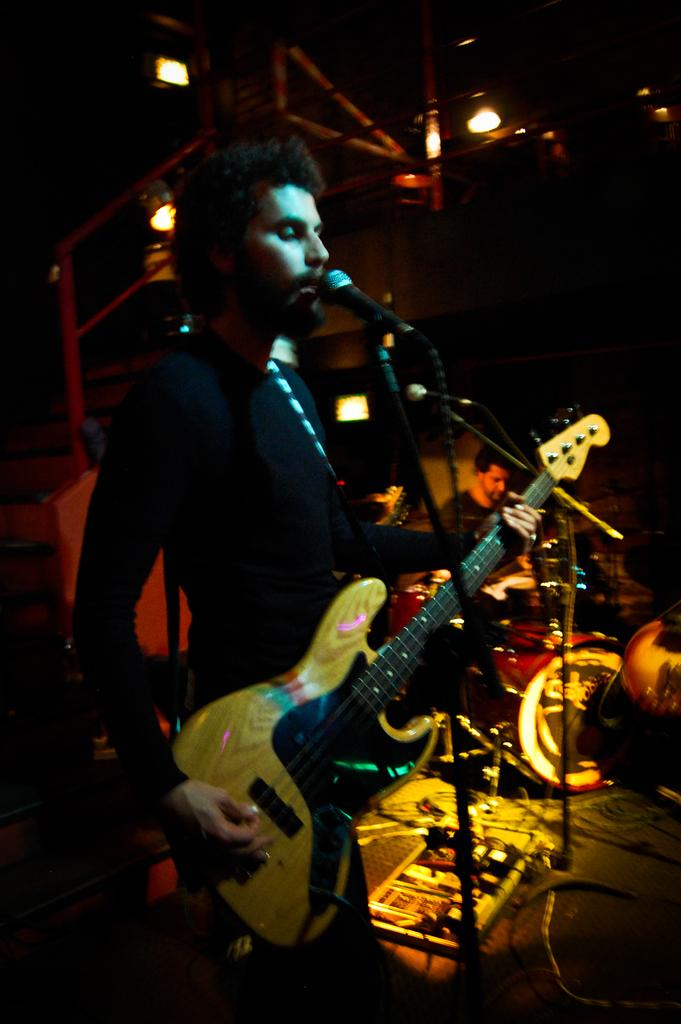What is the man in the image doing? The man is playing a guitar and singing in the image. What object is the man using to amplify his voice? The man is in front of a microphone. What can be seen in the background of the image? There are lights visible in the image. What other musical instrument is the man playing? The man is playing musical instruments, but the provided facts only mention the guitar. What language is the man singing in the image? The provided facts do not mention the language the man is singing in, so it cannot be determined from the image. --- Facts: 1. There is a car in the image. 2. The car is red. 3. The car has four wheels. 4. The car has a license plate. 5. The car has a sunroof. Absurd Topics: bird, ocean, mountain Conversation: What is the color of the car in the image? The car is red. How many wheels does the car have? The car has four wheels. What is a feature of the car that allows for ventilation or visibility? The car has a sunroof. What is a unique identifier for the car? The car has a license plate. Reasoning: Let's think step by step in order to produce the conversation. We start by identifying the main subject in the image, which is the car. Then, we describe the color, number of wheels, and specific features of the car, such as the sunroof and license plate. Each question is designed to elicit a specific detail about the image that is known from the provided facts. Absurd Question/Answer: Can you see any birds flying over the ocean near the mountain in the image? There are no birds, ocean, or mountains present in the image; it features a red car with four wheels, a sunroof, and a license plate. 